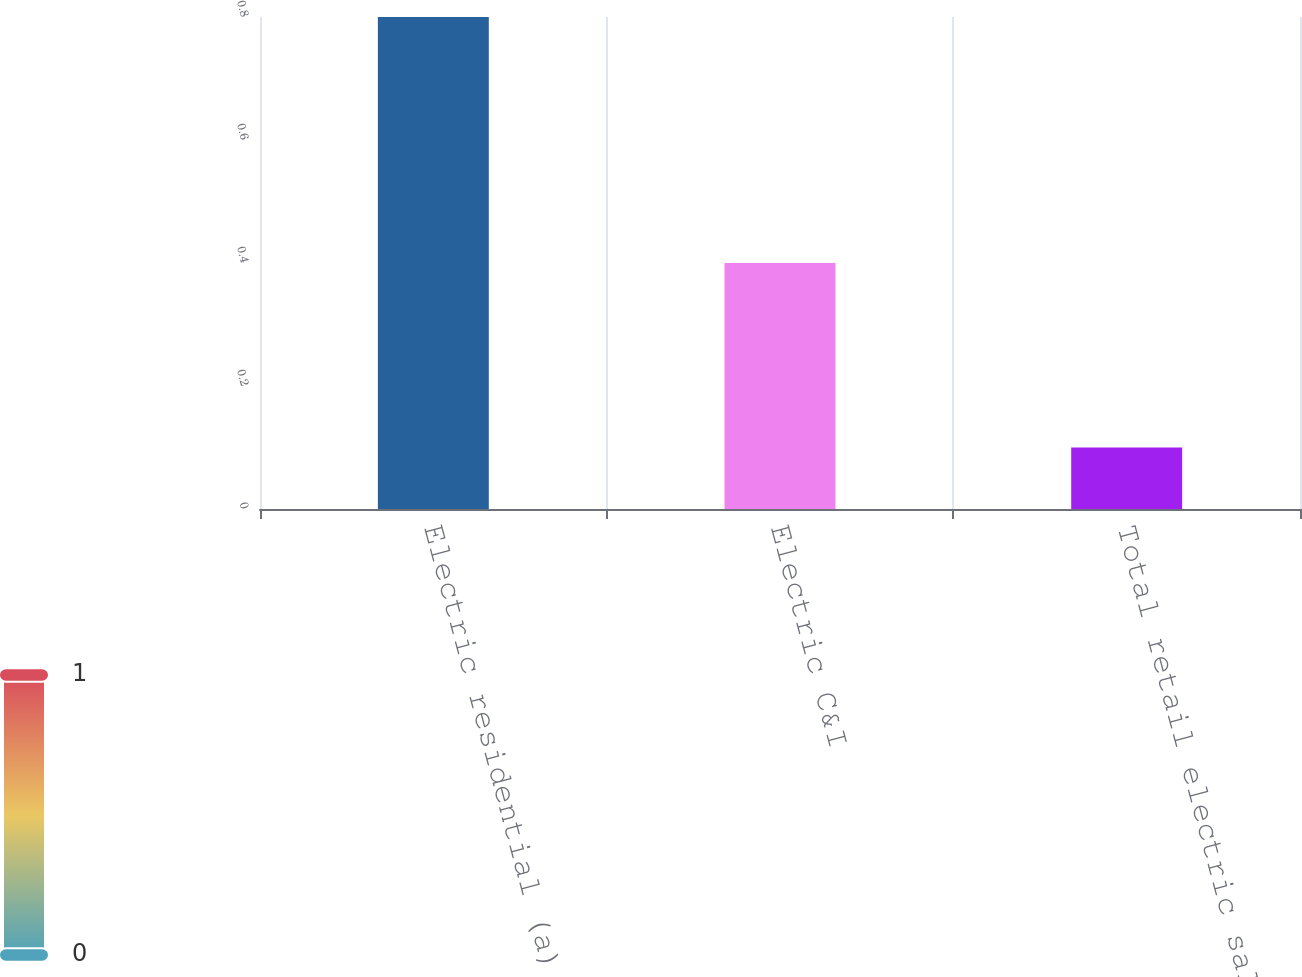Convert chart. <chart><loc_0><loc_0><loc_500><loc_500><bar_chart><fcel>Electric residential (a)<fcel>Electric C&I<fcel>Total retail electric sales<nl><fcel>0.8<fcel>0.4<fcel>0.1<nl></chart> 